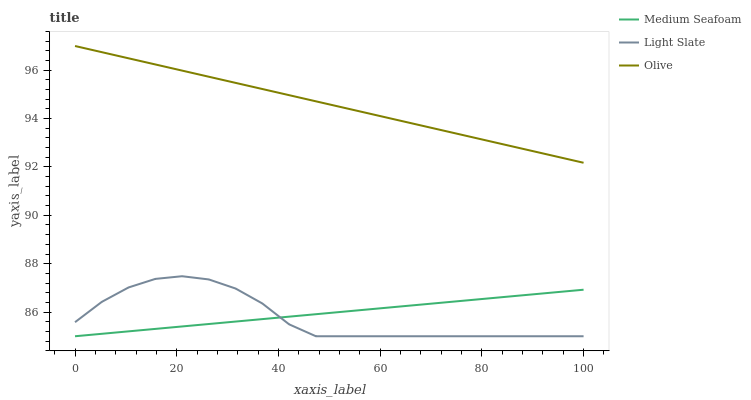Does Light Slate have the minimum area under the curve?
Answer yes or no. Yes. Does Olive have the maximum area under the curve?
Answer yes or no. Yes. Does Medium Seafoam have the minimum area under the curve?
Answer yes or no. No. Does Medium Seafoam have the maximum area under the curve?
Answer yes or no. No. Is Medium Seafoam the smoothest?
Answer yes or no. Yes. Is Light Slate the roughest?
Answer yes or no. Yes. Is Olive the smoothest?
Answer yes or no. No. Is Olive the roughest?
Answer yes or no. No. Does Light Slate have the lowest value?
Answer yes or no. Yes. Does Olive have the lowest value?
Answer yes or no. No. Does Olive have the highest value?
Answer yes or no. Yes. Does Medium Seafoam have the highest value?
Answer yes or no. No. Is Light Slate less than Olive?
Answer yes or no. Yes. Is Olive greater than Light Slate?
Answer yes or no. Yes. Does Light Slate intersect Medium Seafoam?
Answer yes or no. Yes. Is Light Slate less than Medium Seafoam?
Answer yes or no. No. Is Light Slate greater than Medium Seafoam?
Answer yes or no. No. Does Light Slate intersect Olive?
Answer yes or no. No. 